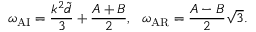Convert formula to latex. <formula><loc_0><loc_0><loc_500><loc_500>\omega _ { A I } = \frac { k ^ { 2 } \widetilde { d } } { 3 } + \frac { A + B } { 2 } , \omega _ { A R } = \frac { A - B } { 2 } \sqrt { 3 } .</formula> 